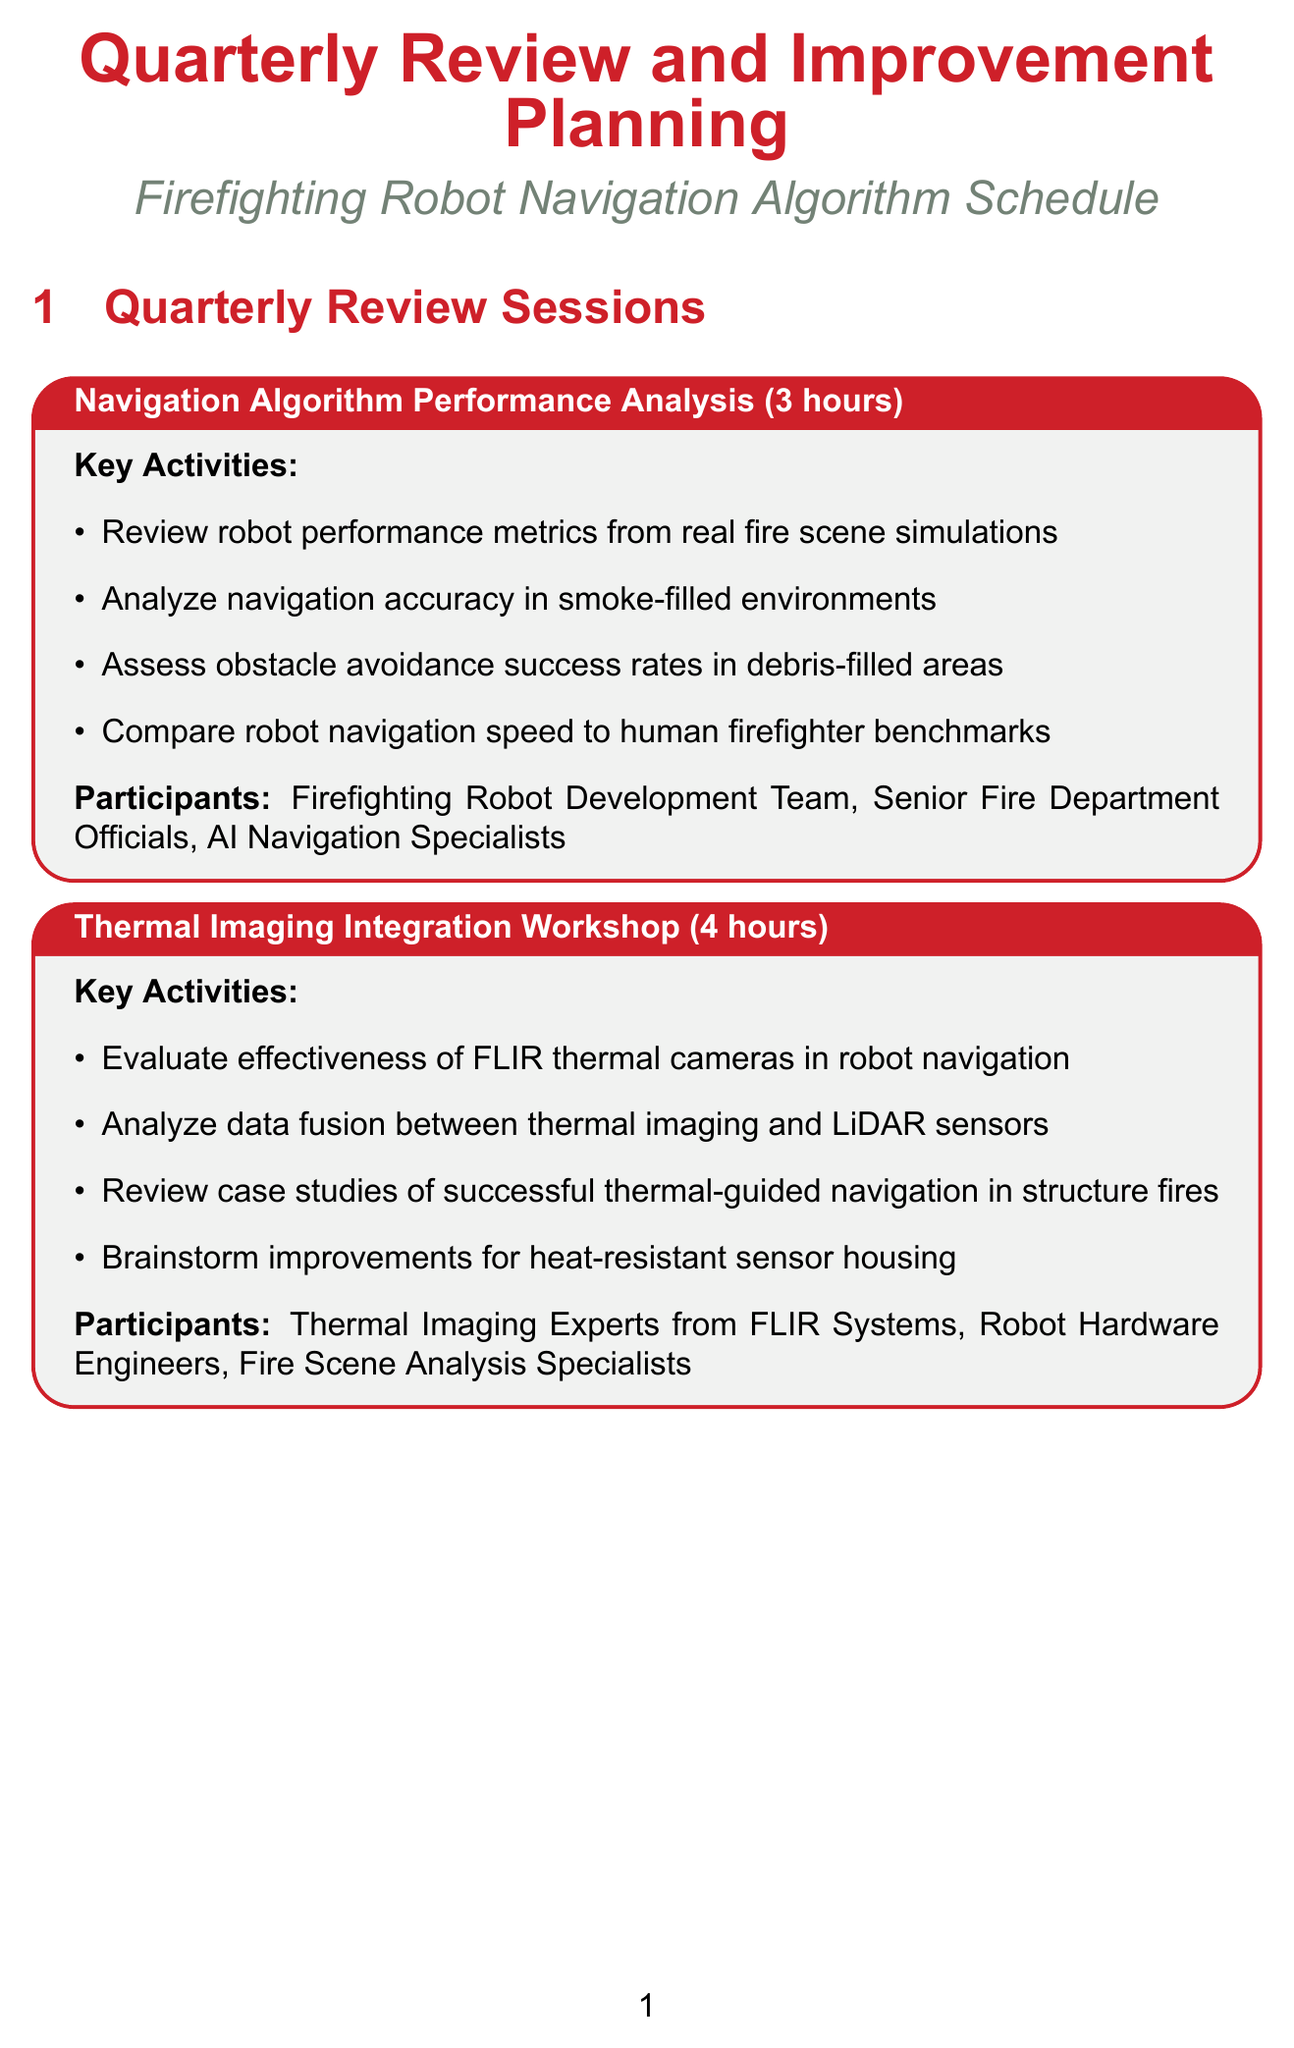What is the duration of the Navigation Algorithm Performance Analysis session? The duration is explicitly stated in the session description as 3 hours.
Answer: 3 hours Who are the participants in the Thermal Imaging Integration Workshop? The participants are listed in the session description, which includes Thermal Imaging Experts, Robot Hardware Engineers, and Fire Scene Analysis Specialists.
Answer: Thermal Imaging Experts from FLIR Systems, Robot Hardware Engineers, Fire Scene Analysis Specialists What key activity is planned during the Machine Learning Model Update Planning session? The session description details specific activities, one of which is to review the performance of current CNN models in identifying fire hazards.
Answer: Review performance of current CNN models in identifying fire hazards What is the total number of hours allocated for the Improvement Planning Sessions? Each session's duration is summed up: 4 + 3 + 3 + 2 + 3 = 15 hours total.
Answer: 15 hours What is one of the key activities for the Human-Robot Interaction Improvement Forum? The key activities are outlined, including analyzing feedback from firefighters on robot control interfaces, which is one of the key focuses.
Answer: Analyze feedback from firefighters on robot control interfaces What is the focus of the Regulatory Compliance and Safety Update session? The main focus areas are specifically mentioned, including reviewing NFPA guidelines for robotics in firefighting, which determines the session's agenda.
Answer: Review latest NFPA guidelines for robotics in firefighting 